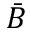<formula> <loc_0><loc_0><loc_500><loc_500>\bar { B }</formula> 